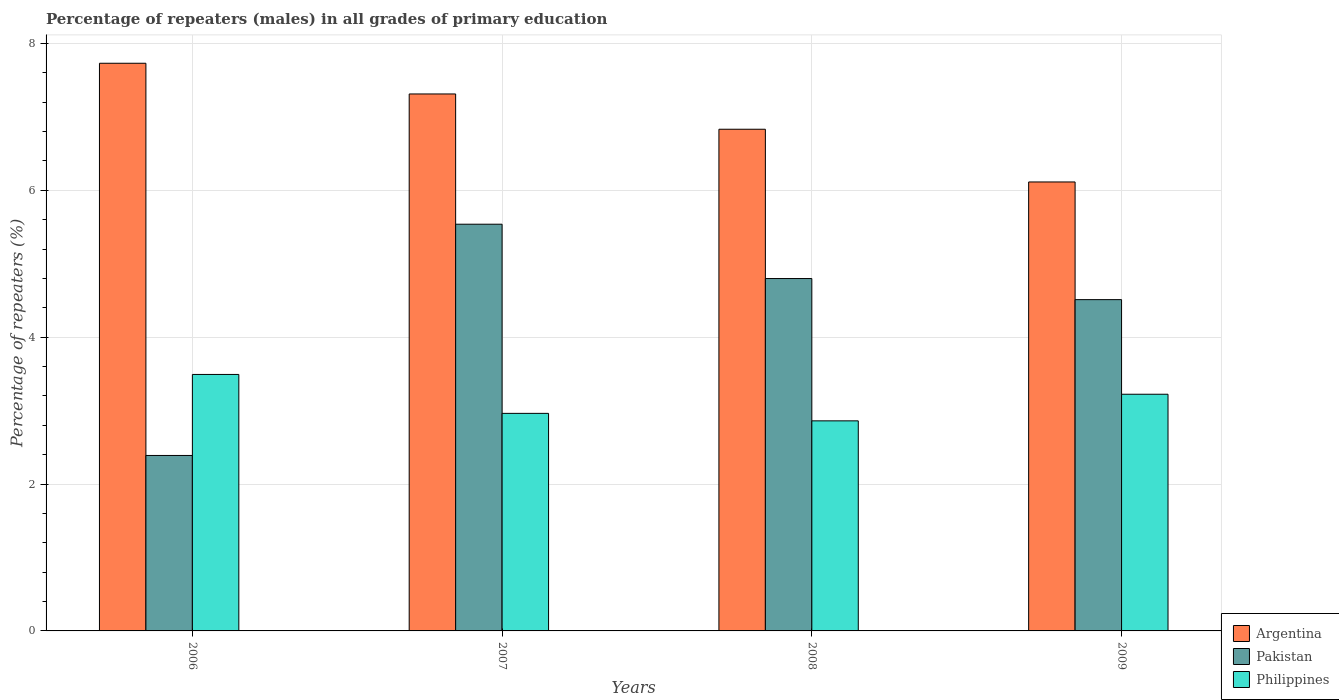How many different coloured bars are there?
Give a very brief answer. 3. How many bars are there on the 3rd tick from the right?
Provide a succinct answer. 3. What is the percentage of repeaters (males) in Philippines in 2006?
Offer a terse response. 3.49. Across all years, what is the maximum percentage of repeaters (males) in Argentina?
Offer a terse response. 7.73. Across all years, what is the minimum percentage of repeaters (males) in Argentina?
Ensure brevity in your answer.  6.11. In which year was the percentage of repeaters (males) in Argentina maximum?
Ensure brevity in your answer.  2006. What is the total percentage of repeaters (males) in Pakistan in the graph?
Your answer should be very brief. 17.24. What is the difference between the percentage of repeaters (males) in Philippines in 2006 and that in 2007?
Give a very brief answer. 0.53. What is the difference between the percentage of repeaters (males) in Pakistan in 2009 and the percentage of repeaters (males) in Argentina in 2006?
Provide a succinct answer. -3.22. What is the average percentage of repeaters (males) in Argentina per year?
Make the answer very short. 7. In the year 2008, what is the difference between the percentage of repeaters (males) in Pakistan and percentage of repeaters (males) in Argentina?
Offer a terse response. -2.03. What is the ratio of the percentage of repeaters (males) in Philippines in 2006 to that in 2009?
Your response must be concise. 1.08. Is the percentage of repeaters (males) in Argentina in 2007 less than that in 2008?
Ensure brevity in your answer.  No. Is the difference between the percentage of repeaters (males) in Pakistan in 2007 and 2009 greater than the difference between the percentage of repeaters (males) in Argentina in 2007 and 2009?
Your answer should be very brief. No. What is the difference between the highest and the second highest percentage of repeaters (males) in Pakistan?
Your response must be concise. 0.74. What is the difference between the highest and the lowest percentage of repeaters (males) in Pakistan?
Your answer should be compact. 3.15. Is the sum of the percentage of repeaters (males) in Argentina in 2007 and 2009 greater than the maximum percentage of repeaters (males) in Pakistan across all years?
Keep it short and to the point. Yes. Is it the case that in every year, the sum of the percentage of repeaters (males) in Pakistan and percentage of repeaters (males) in Argentina is greater than the percentage of repeaters (males) in Philippines?
Your answer should be very brief. Yes. Are all the bars in the graph horizontal?
Give a very brief answer. No. How many years are there in the graph?
Your answer should be very brief. 4. What is the difference between two consecutive major ticks on the Y-axis?
Your answer should be very brief. 2. Where does the legend appear in the graph?
Provide a short and direct response. Bottom right. How many legend labels are there?
Give a very brief answer. 3. How are the legend labels stacked?
Ensure brevity in your answer.  Vertical. What is the title of the graph?
Make the answer very short. Percentage of repeaters (males) in all grades of primary education. What is the label or title of the X-axis?
Make the answer very short. Years. What is the label or title of the Y-axis?
Give a very brief answer. Percentage of repeaters (%). What is the Percentage of repeaters (%) of Argentina in 2006?
Provide a succinct answer. 7.73. What is the Percentage of repeaters (%) in Pakistan in 2006?
Keep it short and to the point. 2.39. What is the Percentage of repeaters (%) in Philippines in 2006?
Your answer should be compact. 3.49. What is the Percentage of repeaters (%) of Argentina in 2007?
Provide a short and direct response. 7.31. What is the Percentage of repeaters (%) in Pakistan in 2007?
Offer a very short reply. 5.54. What is the Percentage of repeaters (%) of Philippines in 2007?
Keep it short and to the point. 2.96. What is the Percentage of repeaters (%) of Argentina in 2008?
Your answer should be very brief. 6.83. What is the Percentage of repeaters (%) of Pakistan in 2008?
Offer a very short reply. 4.8. What is the Percentage of repeaters (%) of Philippines in 2008?
Ensure brevity in your answer.  2.86. What is the Percentage of repeaters (%) in Argentina in 2009?
Offer a very short reply. 6.11. What is the Percentage of repeaters (%) in Pakistan in 2009?
Provide a short and direct response. 4.51. What is the Percentage of repeaters (%) of Philippines in 2009?
Your answer should be compact. 3.22. Across all years, what is the maximum Percentage of repeaters (%) of Argentina?
Give a very brief answer. 7.73. Across all years, what is the maximum Percentage of repeaters (%) of Pakistan?
Your answer should be compact. 5.54. Across all years, what is the maximum Percentage of repeaters (%) of Philippines?
Keep it short and to the point. 3.49. Across all years, what is the minimum Percentage of repeaters (%) in Argentina?
Offer a very short reply. 6.11. Across all years, what is the minimum Percentage of repeaters (%) of Pakistan?
Your answer should be very brief. 2.39. Across all years, what is the minimum Percentage of repeaters (%) of Philippines?
Your answer should be compact. 2.86. What is the total Percentage of repeaters (%) in Argentina in the graph?
Your response must be concise. 27.99. What is the total Percentage of repeaters (%) of Pakistan in the graph?
Your answer should be compact. 17.24. What is the total Percentage of repeaters (%) of Philippines in the graph?
Provide a short and direct response. 12.54. What is the difference between the Percentage of repeaters (%) in Argentina in 2006 and that in 2007?
Offer a terse response. 0.42. What is the difference between the Percentage of repeaters (%) of Pakistan in 2006 and that in 2007?
Ensure brevity in your answer.  -3.15. What is the difference between the Percentage of repeaters (%) in Philippines in 2006 and that in 2007?
Ensure brevity in your answer.  0.53. What is the difference between the Percentage of repeaters (%) in Argentina in 2006 and that in 2008?
Give a very brief answer. 0.9. What is the difference between the Percentage of repeaters (%) in Pakistan in 2006 and that in 2008?
Ensure brevity in your answer.  -2.41. What is the difference between the Percentage of repeaters (%) in Philippines in 2006 and that in 2008?
Give a very brief answer. 0.63. What is the difference between the Percentage of repeaters (%) in Argentina in 2006 and that in 2009?
Your answer should be very brief. 1.62. What is the difference between the Percentage of repeaters (%) in Pakistan in 2006 and that in 2009?
Your answer should be very brief. -2.12. What is the difference between the Percentage of repeaters (%) in Philippines in 2006 and that in 2009?
Offer a terse response. 0.27. What is the difference between the Percentage of repeaters (%) of Argentina in 2007 and that in 2008?
Ensure brevity in your answer.  0.48. What is the difference between the Percentage of repeaters (%) of Pakistan in 2007 and that in 2008?
Offer a terse response. 0.74. What is the difference between the Percentage of repeaters (%) of Philippines in 2007 and that in 2008?
Offer a very short reply. 0.1. What is the difference between the Percentage of repeaters (%) in Argentina in 2007 and that in 2009?
Your answer should be compact. 1.2. What is the difference between the Percentage of repeaters (%) in Pakistan in 2007 and that in 2009?
Provide a short and direct response. 1.03. What is the difference between the Percentage of repeaters (%) of Philippines in 2007 and that in 2009?
Offer a very short reply. -0.26. What is the difference between the Percentage of repeaters (%) of Argentina in 2008 and that in 2009?
Your response must be concise. 0.72. What is the difference between the Percentage of repeaters (%) in Pakistan in 2008 and that in 2009?
Provide a short and direct response. 0.29. What is the difference between the Percentage of repeaters (%) of Philippines in 2008 and that in 2009?
Give a very brief answer. -0.36. What is the difference between the Percentage of repeaters (%) of Argentina in 2006 and the Percentage of repeaters (%) of Pakistan in 2007?
Make the answer very short. 2.19. What is the difference between the Percentage of repeaters (%) of Argentina in 2006 and the Percentage of repeaters (%) of Philippines in 2007?
Your answer should be very brief. 4.77. What is the difference between the Percentage of repeaters (%) in Pakistan in 2006 and the Percentage of repeaters (%) in Philippines in 2007?
Provide a short and direct response. -0.57. What is the difference between the Percentage of repeaters (%) in Argentina in 2006 and the Percentage of repeaters (%) in Pakistan in 2008?
Your answer should be very brief. 2.93. What is the difference between the Percentage of repeaters (%) in Argentina in 2006 and the Percentage of repeaters (%) in Philippines in 2008?
Offer a very short reply. 4.87. What is the difference between the Percentage of repeaters (%) in Pakistan in 2006 and the Percentage of repeaters (%) in Philippines in 2008?
Your answer should be very brief. -0.47. What is the difference between the Percentage of repeaters (%) of Argentina in 2006 and the Percentage of repeaters (%) of Pakistan in 2009?
Offer a terse response. 3.22. What is the difference between the Percentage of repeaters (%) in Argentina in 2006 and the Percentage of repeaters (%) in Philippines in 2009?
Your answer should be compact. 4.51. What is the difference between the Percentage of repeaters (%) of Pakistan in 2006 and the Percentage of repeaters (%) of Philippines in 2009?
Offer a very short reply. -0.83. What is the difference between the Percentage of repeaters (%) in Argentina in 2007 and the Percentage of repeaters (%) in Pakistan in 2008?
Provide a short and direct response. 2.51. What is the difference between the Percentage of repeaters (%) in Argentina in 2007 and the Percentage of repeaters (%) in Philippines in 2008?
Your answer should be very brief. 4.45. What is the difference between the Percentage of repeaters (%) of Pakistan in 2007 and the Percentage of repeaters (%) of Philippines in 2008?
Your answer should be very brief. 2.68. What is the difference between the Percentage of repeaters (%) of Argentina in 2007 and the Percentage of repeaters (%) of Pakistan in 2009?
Give a very brief answer. 2.8. What is the difference between the Percentage of repeaters (%) in Argentina in 2007 and the Percentage of repeaters (%) in Philippines in 2009?
Keep it short and to the point. 4.09. What is the difference between the Percentage of repeaters (%) in Pakistan in 2007 and the Percentage of repeaters (%) in Philippines in 2009?
Make the answer very short. 2.32. What is the difference between the Percentage of repeaters (%) in Argentina in 2008 and the Percentage of repeaters (%) in Pakistan in 2009?
Your response must be concise. 2.32. What is the difference between the Percentage of repeaters (%) of Argentina in 2008 and the Percentage of repeaters (%) of Philippines in 2009?
Make the answer very short. 3.61. What is the difference between the Percentage of repeaters (%) in Pakistan in 2008 and the Percentage of repeaters (%) in Philippines in 2009?
Provide a succinct answer. 1.58. What is the average Percentage of repeaters (%) of Argentina per year?
Keep it short and to the point. 7. What is the average Percentage of repeaters (%) in Pakistan per year?
Offer a very short reply. 4.31. What is the average Percentage of repeaters (%) in Philippines per year?
Offer a very short reply. 3.13. In the year 2006, what is the difference between the Percentage of repeaters (%) in Argentina and Percentage of repeaters (%) in Pakistan?
Your answer should be compact. 5.34. In the year 2006, what is the difference between the Percentage of repeaters (%) in Argentina and Percentage of repeaters (%) in Philippines?
Ensure brevity in your answer.  4.24. In the year 2006, what is the difference between the Percentage of repeaters (%) in Pakistan and Percentage of repeaters (%) in Philippines?
Your response must be concise. -1.1. In the year 2007, what is the difference between the Percentage of repeaters (%) of Argentina and Percentage of repeaters (%) of Pakistan?
Provide a short and direct response. 1.77. In the year 2007, what is the difference between the Percentage of repeaters (%) in Argentina and Percentage of repeaters (%) in Philippines?
Make the answer very short. 4.35. In the year 2007, what is the difference between the Percentage of repeaters (%) of Pakistan and Percentage of repeaters (%) of Philippines?
Make the answer very short. 2.58. In the year 2008, what is the difference between the Percentage of repeaters (%) in Argentina and Percentage of repeaters (%) in Pakistan?
Provide a short and direct response. 2.03. In the year 2008, what is the difference between the Percentage of repeaters (%) of Argentina and Percentage of repeaters (%) of Philippines?
Ensure brevity in your answer.  3.97. In the year 2008, what is the difference between the Percentage of repeaters (%) in Pakistan and Percentage of repeaters (%) in Philippines?
Keep it short and to the point. 1.94. In the year 2009, what is the difference between the Percentage of repeaters (%) of Argentina and Percentage of repeaters (%) of Pakistan?
Your answer should be compact. 1.6. In the year 2009, what is the difference between the Percentage of repeaters (%) of Argentina and Percentage of repeaters (%) of Philippines?
Keep it short and to the point. 2.89. In the year 2009, what is the difference between the Percentage of repeaters (%) in Pakistan and Percentage of repeaters (%) in Philippines?
Make the answer very short. 1.29. What is the ratio of the Percentage of repeaters (%) of Argentina in 2006 to that in 2007?
Offer a terse response. 1.06. What is the ratio of the Percentage of repeaters (%) of Pakistan in 2006 to that in 2007?
Keep it short and to the point. 0.43. What is the ratio of the Percentage of repeaters (%) in Philippines in 2006 to that in 2007?
Your answer should be compact. 1.18. What is the ratio of the Percentage of repeaters (%) in Argentina in 2006 to that in 2008?
Your answer should be compact. 1.13. What is the ratio of the Percentage of repeaters (%) of Pakistan in 2006 to that in 2008?
Keep it short and to the point. 0.5. What is the ratio of the Percentage of repeaters (%) of Philippines in 2006 to that in 2008?
Your response must be concise. 1.22. What is the ratio of the Percentage of repeaters (%) in Argentina in 2006 to that in 2009?
Provide a succinct answer. 1.26. What is the ratio of the Percentage of repeaters (%) of Pakistan in 2006 to that in 2009?
Your answer should be very brief. 0.53. What is the ratio of the Percentage of repeaters (%) in Philippines in 2006 to that in 2009?
Make the answer very short. 1.08. What is the ratio of the Percentage of repeaters (%) in Argentina in 2007 to that in 2008?
Provide a succinct answer. 1.07. What is the ratio of the Percentage of repeaters (%) of Pakistan in 2007 to that in 2008?
Provide a short and direct response. 1.15. What is the ratio of the Percentage of repeaters (%) of Philippines in 2007 to that in 2008?
Offer a very short reply. 1.04. What is the ratio of the Percentage of repeaters (%) in Argentina in 2007 to that in 2009?
Offer a very short reply. 1.2. What is the ratio of the Percentage of repeaters (%) in Pakistan in 2007 to that in 2009?
Provide a short and direct response. 1.23. What is the ratio of the Percentage of repeaters (%) of Philippines in 2007 to that in 2009?
Ensure brevity in your answer.  0.92. What is the ratio of the Percentage of repeaters (%) of Argentina in 2008 to that in 2009?
Keep it short and to the point. 1.12. What is the ratio of the Percentage of repeaters (%) of Pakistan in 2008 to that in 2009?
Provide a succinct answer. 1.06. What is the ratio of the Percentage of repeaters (%) in Philippines in 2008 to that in 2009?
Ensure brevity in your answer.  0.89. What is the difference between the highest and the second highest Percentage of repeaters (%) of Argentina?
Provide a short and direct response. 0.42. What is the difference between the highest and the second highest Percentage of repeaters (%) in Pakistan?
Give a very brief answer. 0.74. What is the difference between the highest and the second highest Percentage of repeaters (%) in Philippines?
Ensure brevity in your answer.  0.27. What is the difference between the highest and the lowest Percentage of repeaters (%) of Argentina?
Make the answer very short. 1.62. What is the difference between the highest and the lowest Percentage of repeaters (%) of Pakistan?
Keep it short and to the point. 3.15. What is the difference between the highest and the lowest Percentage of repeaters (%) of Philippines?
Your response must be concise. 0.63. 